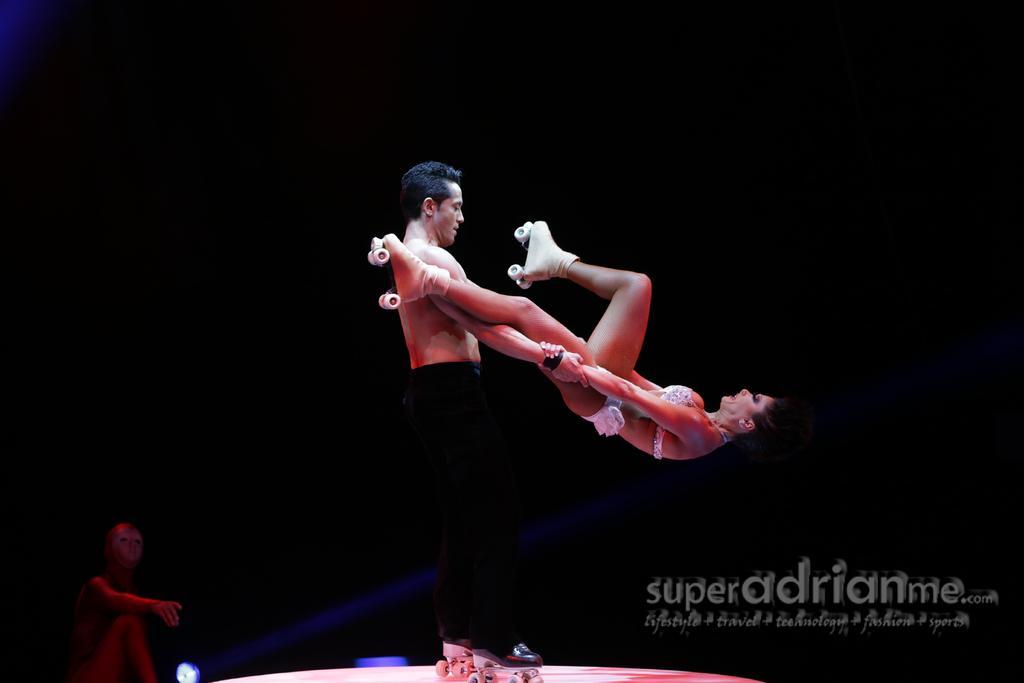Describe this image in one or two sentences. In this image I can see two people with the skate shoes. To the left I can see another person and I can see the black background. 